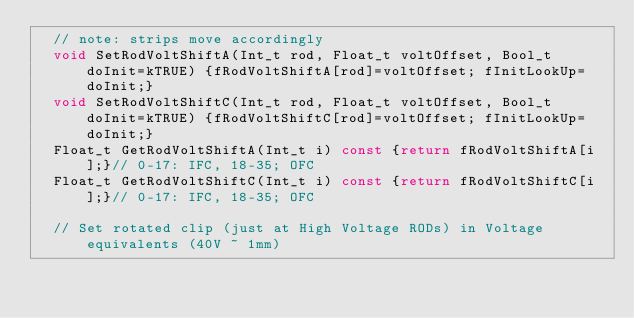<code> <loc_0><loc_0><loc_500><loc_500><_C_>  // note: strips move accordingly
  void SetRodVoltShiftA(Int_t rod, Float_t voltOffset, Bool_t doInit=kTRUE) {fRodVoltShiftA[rod]=voltOffset; fInitLookUp=doInit;}
  void SetRodVoltShiftC(Int_t rod, Float_t voltOffset, Bool_t doInit=kTRUE) {fRodVoltShiftC[rod]=voltOffset; fInitLookUp=doInit;}
  Float_t GetRodVoltShiftA(Int_t i) const {return fRodVoltShiftA[i];}// 0-17: IFC, 18-35; OFC
  Float_t GetRodVoltShiftC(Int_t i) const {return fRodVoltShiftC[i];}// 0-17: IFC, 18-35; OFC

  // Set rotated clip (just at High Voltage RODs) in Voltage equivalents (40V ~ 1mm)</code> 